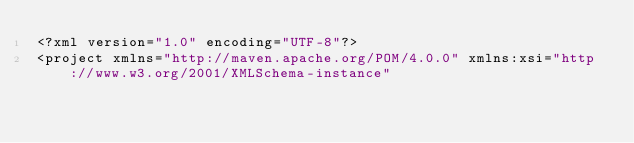Convert code to text. <code><loc_0><loc_0><loc_500><loc_500><_XML_><?xml version="1.0" encoding="UTF-8"?>
<project xmlns="http://maven.apache.org/POM/4.0.0" xmlns:xsi="http://www.w3.org/2001/XMLSchema-instance"</code> 